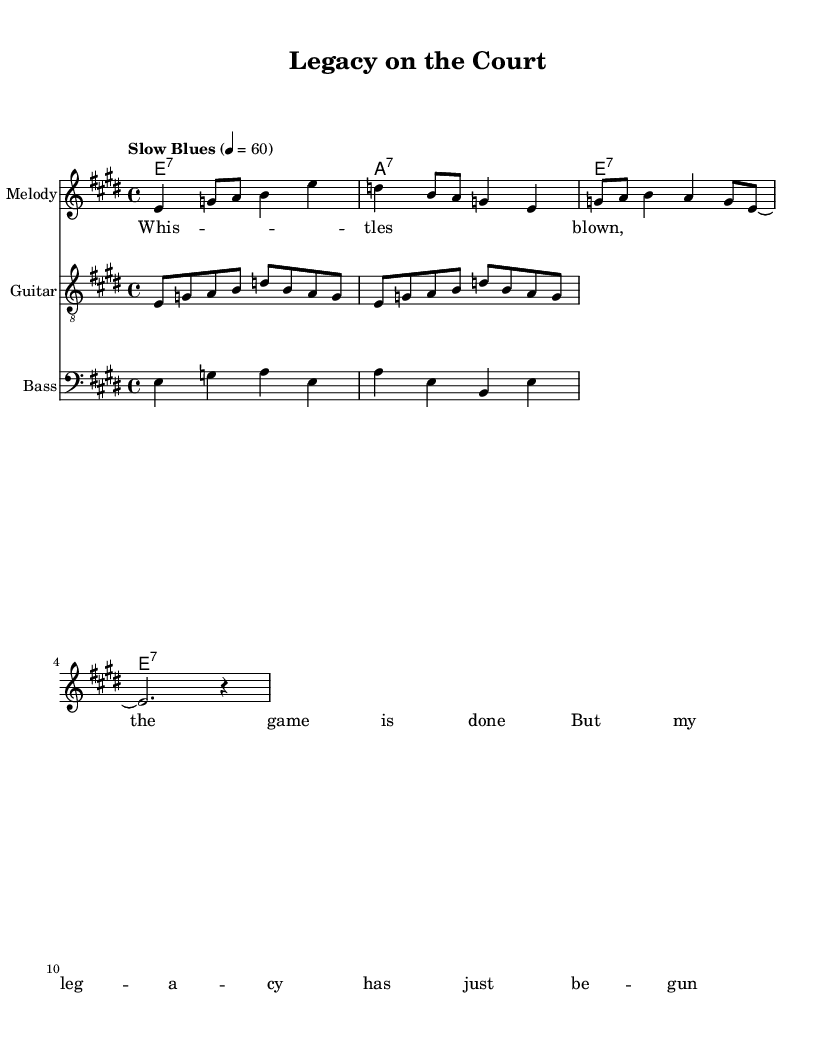What is the key signature of this music? The key signature indicated at the beginning of the sheet music is E major, which has four sharps (F#, C#, G#, D#). This is determined by the "e" note in the key signature line.
Answer: E major What is the time signature of this music? The time signature shown at the beginning of the score is 4/4, which indicates that there are four beats in each measure and the quarter note gets one beat. This is represented by the "4" over the "4" in the time signature notation.
Answer: 4/4 What is the tempo marking for this piece? The tempo marking at the start of the music is "Slow Blues," which is to be played at a speed of 60 beats per minute. This is typically noted at the beginning of the sheet music as a descriptive tempo.
Answer: Slow Blues How many measures are in the melody? The melody section consists of four measures, which can be counted by identifying the vertical bar lines that separate each measure in the music. Each segment enclosed between the bar lines counts as one measure.
Answer: Four What chords are played in the harmonies section? The harmonies denote three E7 chords and one A7 chord, which can be identified from the chord names written above the staff in the chord mode. The letter names indicate the chords being played throughout the measures.
Answer: E7, A7 What kind of guitar pattern is used in the piece? The guitar riff features a repeating pattern that follows a typical electric blues style, characterized by its use of a combination of eighth notes in sequences that create a melodic flow. This can be recognized by the notes laid out in the treble clef staff that indicate the riff sequences.
Answer: Repeating pattern What theme does the lyrics explore? The lyrics represent a reflective theme on legacy and the conclusion of a sporting career, highlighted in the text about the end of the game and the beginning of a legacy. This can be derived from analyzing the lyrical line that discusses the transition from playing to reflecting on impact.
Answer: Legacy in sports 